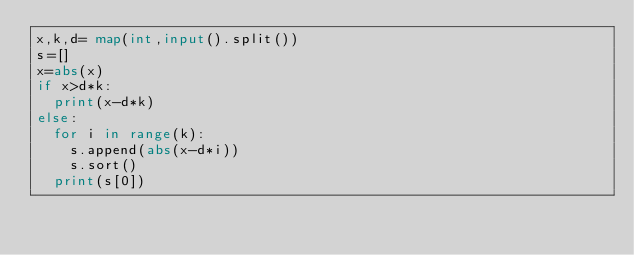Convert code to text. <code><loc_0><loc_0><loc_500><loc_500><_Python_>x,k,d= map(int,input().split())
s=[]
x=abs(x)
if x>d*k:
  print(x-d*k)
else:
  for i in range(k):
    s.append(abs(x-d*i))
    s.sort()
  print(s[0])</code> 